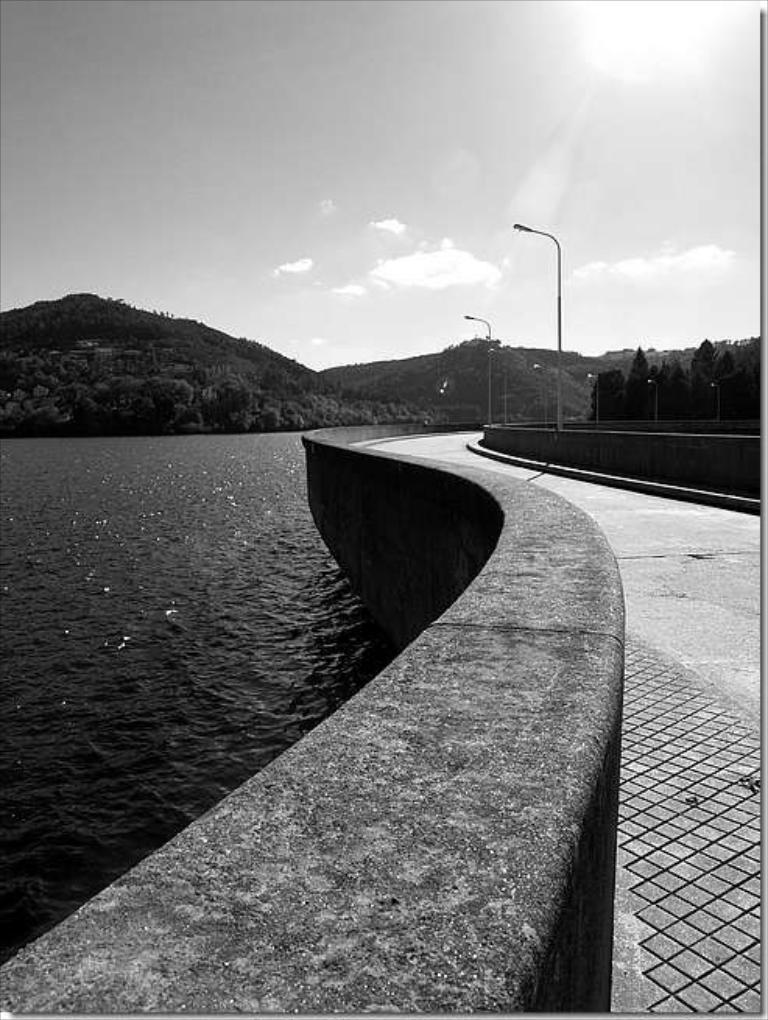In one or two sentences, can you explain what this image depicts? This is a black and white image there is a river in left side and in right side there is road and there are light poles, in the background there are mountains and a sky. 